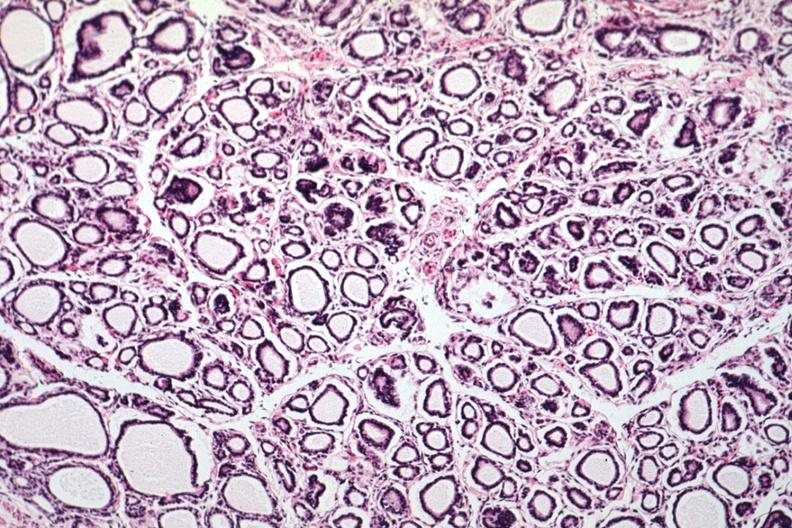what is present?
Answer the question using a single word or phrase. Endocrine 